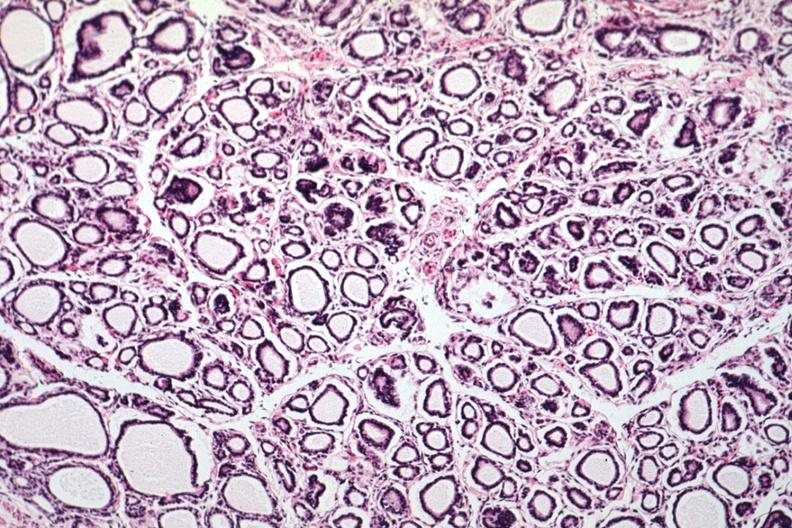what is present?
Answer the question using a single word or phrase. Endocrine 